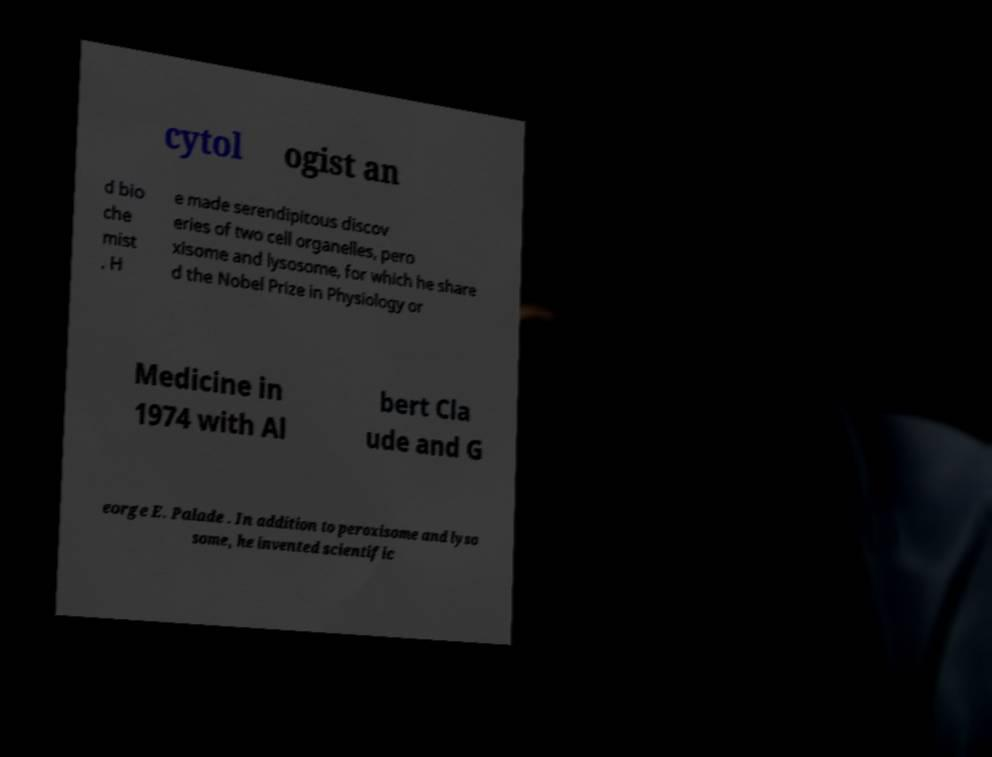Please read and relay the text visible in this image. What does it say? cytol ogist an d bio che mist . H e made serendipitous discov eries of two cell organelles, pero xisome and lysosome, for which he share d the Nobel Prize in Physiology or Medicine in 1974 with Al bert Cla ude and G eorge E. Palade . In addition to peroxisome and lyso some, he invented scientific 